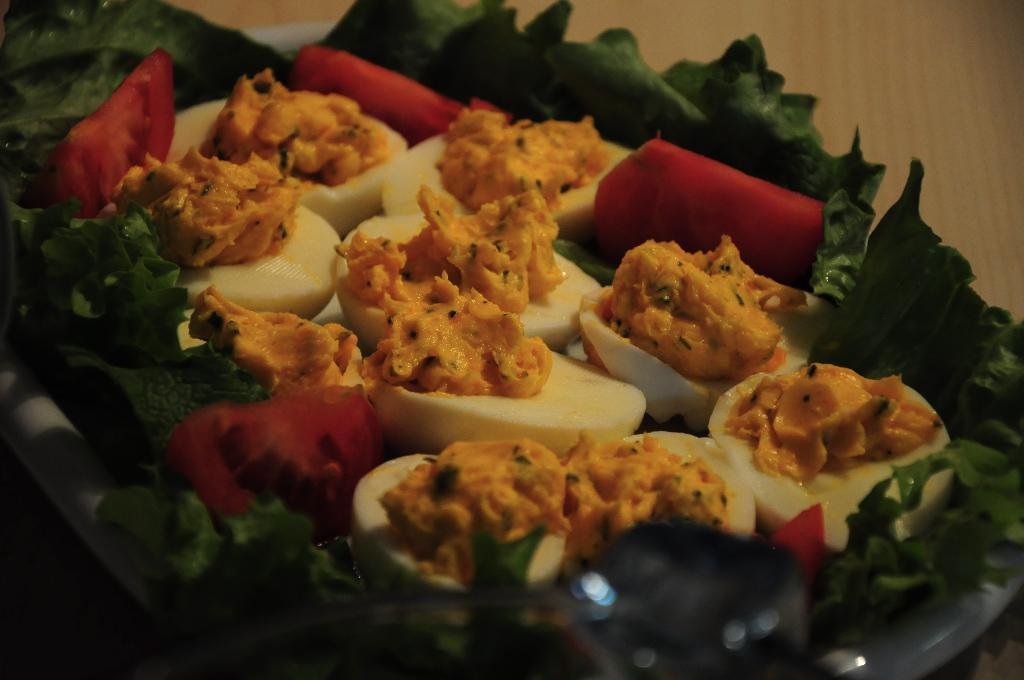What types of objects can be seen in the image? There are food items in the image. Reasoning: Let's think step by step by step in order to produce the conversation. We start by identifying the main subject in the image, which is the food items. Since there is only one fact provided, we formulate a question that focuses on the main subject and can be answered definitively with the information given. We avoid yes/no questions and ensure that the language is simple and clear. Absurd Question/Answer: What type of drum can be seen in the image? There is no drum present in the image; it only contains food items. How many parcels are visible in the image? There are no parcels present in the image; it only contains food items. What type of riddle can be solved using the food items in the image? There is no riddle present in the image; it only contains food items. 